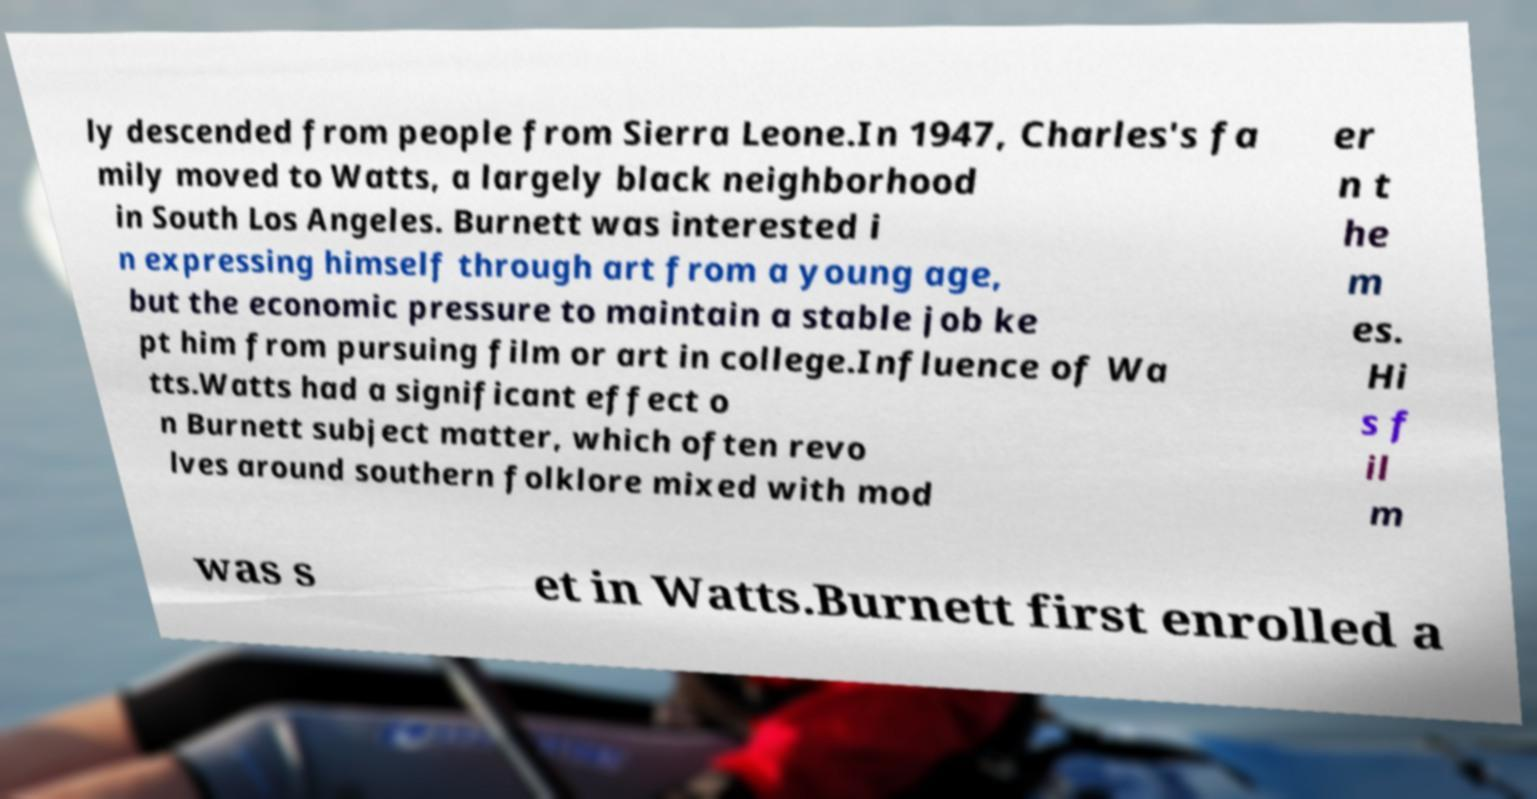Please identify and transcribe the text found in this image. ly descended from people from Sierra Leone.In 1947, Charles's fa mily moved to Watts, a largely black neighborhood in South Los Angeles. Burnett was interested i n expressing himself through art from a young age, but the economic pressure to maintain a stable job ke pt him from pursuing film or art in college.Influence of Wa tts.Watts had a significant effect o n Burnett subject matter, which often revo lves around southern folklore mixed with mod er n t he m es. Hi s f il m was s et in Watts.Burnett first enrolled a 